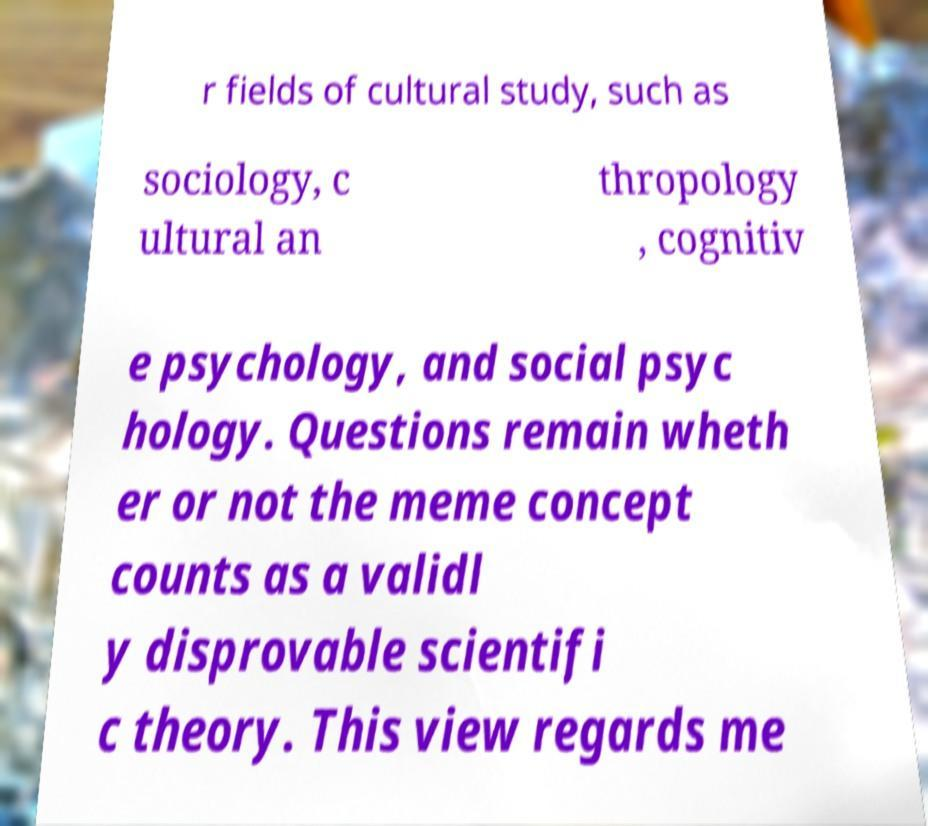For documentation purposes, I need the text within this image transcribed. Could you provide that? r fields of cultural study, such as sociology, c ultural an thropology , cognitiv e psychology, and social psyc hology. Questions remain wheth er or not the meme concept counts as a validl y disprovable scientifi c theory. This view regards me 